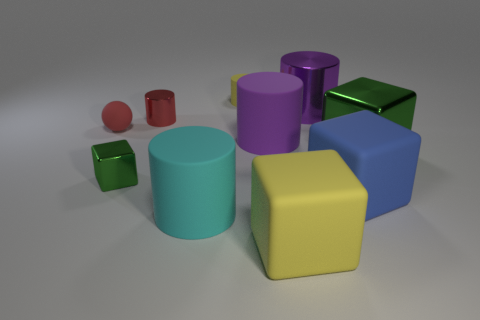Is the number of yellow rubber cubes greater than the number of large things?
Provide a short and direct response. No. There is a big cylinder right of the yellow block; is it the same color as the small cylinder that is behind the big metal cylinder?
Your answer should be compact. No. Are there any shiny things behind the large purple cylinder to the right of the big yellow block?
Your answer should be compact. No. Are there fewer cyan matte objects that are left of the small red ball than green metal blocks on the left side of the cyan matte thing?
Your answer should be compact. Yes. Is the material of the yellow thing that is in front of the large cyan rubber cylinder the same as the large purple cylinder that is in front of the tiny matte sphere?
Provide a succinct answer. Yes. How many small things are green cubes or red rubber things?
Offer a very short reply. 2. What shape is the purple thing that is the same material as the big cyan cylinder?
Provide a short and direct response. Cylinder. Are there fewer blue matte cubes that are in front of the big blue thing than tiny brown metallic balls?
Your answer should be very brief. No. Does the red rubber object have the same shape as the big green object?
Make the answer very short. No. What number of matte objects are either large blue objects or balls?
Your answer should be very brief. 2. 